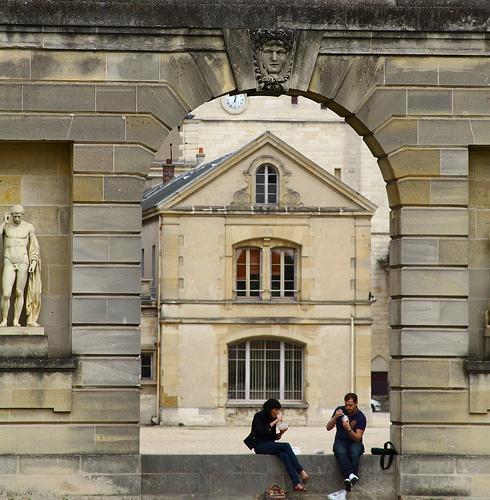How many people are there?
Give a very brief answer. 2. How many people are wearing a short sleeve shirt?
Give a very brief answer. 1. 